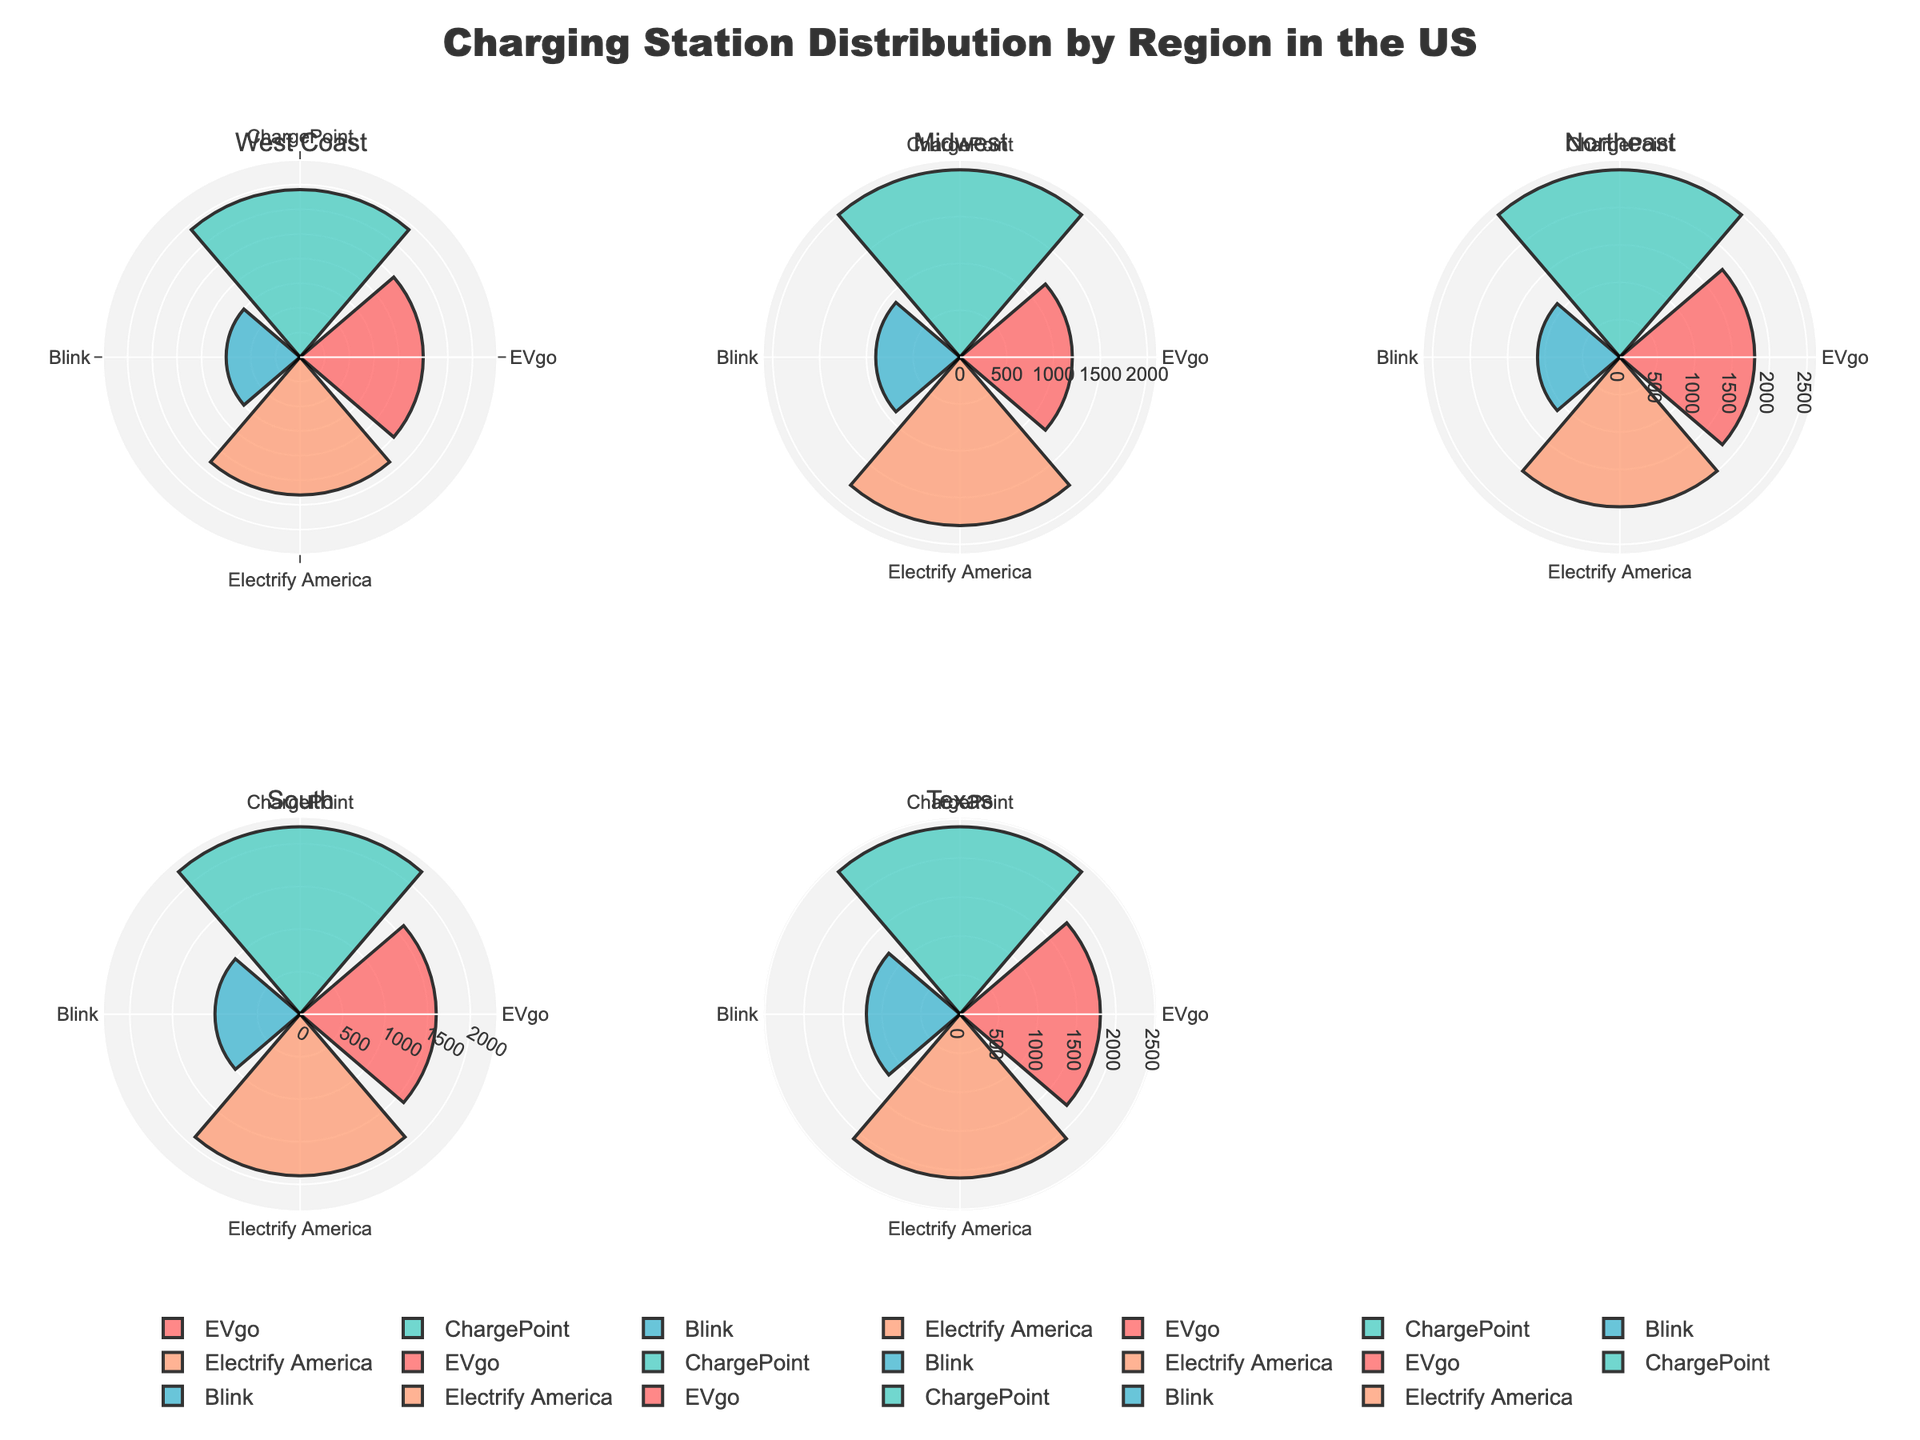what regions are included in the chart? The title of the subplot gives you the regions included. They are "West Coast," "Midwest," "Northeast," "South," and "Texas." This can be easily identified from the subplot titles at the top of each rose chart.
Answer: West Coast, Midwest, Northeast, South, Texas How many charging points does EVgo have on the West Coast? Look specifically at the EVgo segment within the West Coast subplot, represented in one of the colors. The length or size of the segment indicates 2500 charging points.
Answer: 2500 Which charging station has the most points in the Midwest region? By comparing the sizes of the segments for each station in the Midwest subplot, you can see that ChargePoint has the largest segment with 2000 points.
Answer: ChargePoint Are there more EVgo charging points in Texas or in the South? Compare the size of the EVgo segment in the Texas subplot with the EVgo segment in the South subplot. Texas has 1800 EVgo points, while the South has 1600.
Answer: Texas What's the total number of charging points for ChargePoint in all regions? Sum the ChargePoint values from all regions: 3400 (West Coast) + 2000 (Midwest) + 2500 (Northeast) + 2200 (South) + 2400 (Texas) = 12500.
Answer: 12500 Is the number of Blink charging points higher in the Northeast or the Midwest? Compare the Blink segments in both the Northeast and Midwest subplots. The Northeast has 1100 Blink points while the Midwest has 900.
Answer: Northeast Which region has the smallest number of Electrify America charging points? Identify the smallest Electrify America segment across all regions: West Coast (2800), Midwest (1800), Northeast (2000), South (1900), Texas (2100). Midwest has the smallest number with 1800 points.
Answer: Midwest What's the average number of charging points for EVgo across all regions? Calculate the average by summing EVgo points and then dividing by the number of regions: (2500 + 1200 + 1800 + 1600 + 1800) / 5 = 8900 / 5 = 1780.
Answer: 1780 